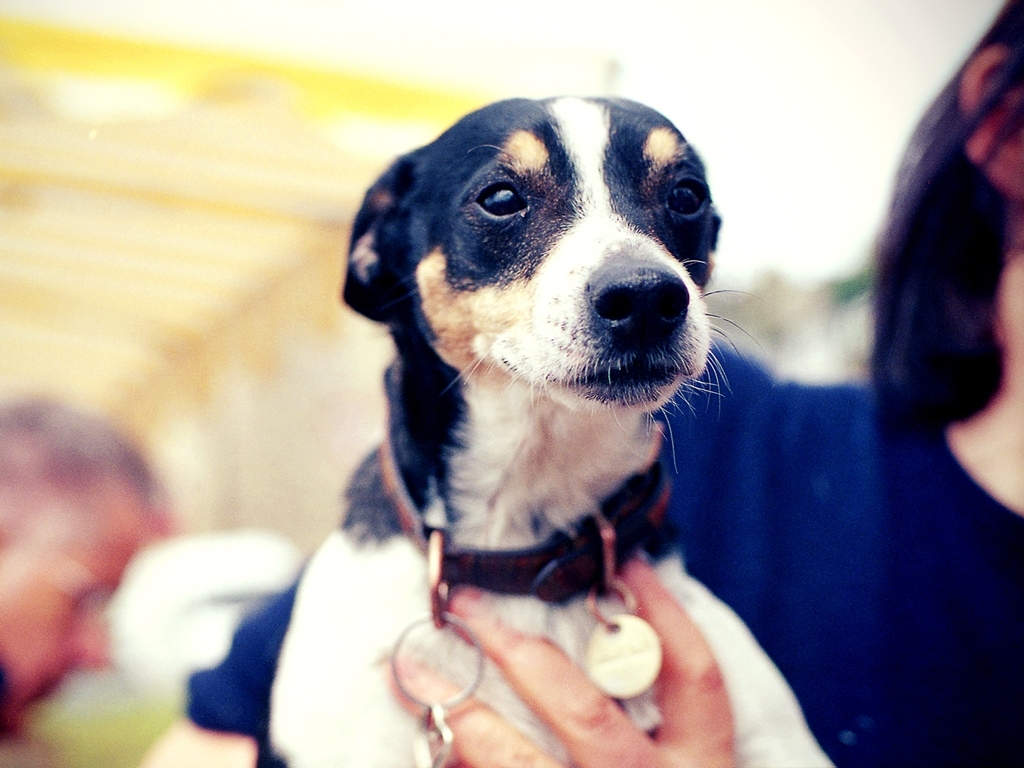Can you describe the setting of this image? The setting looks informal, likely outdoors at a gathering or event, with diffuse natural lighting and blurred figures in the background hinting at movement and activity. 